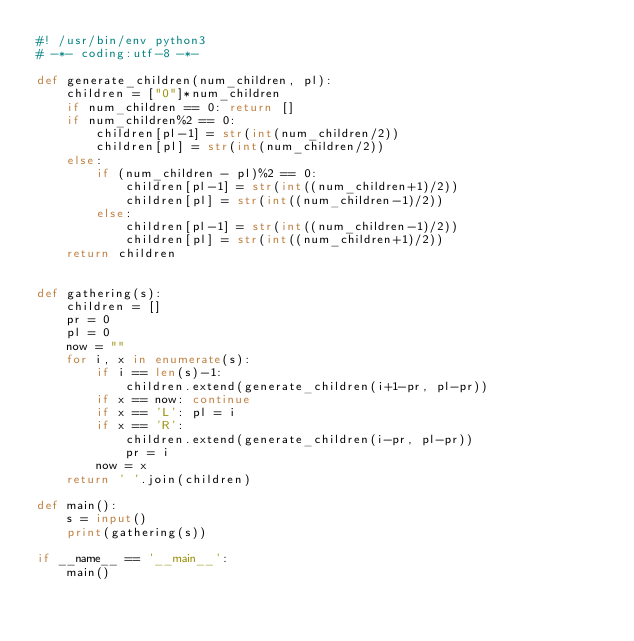Convert code to text. <code><loc_0><loc_0><loc_500><loc_500><_Python_>#! /usr/bin/env python3
# -*- coding:utf-8 -*-

def generate_children(num_children, pl):
    children = ["0"]*num_children
    if num_children == 0: return []
    if num_children%2 == 0:
        children[pl-1] = str(int(num_children/2))
        children[pl] = str(int(num_children/2))
    else:
        if (num_children - pl)%2 == 0:
            children[pl-1] = str(int((num_children+1)/2))
            children[pl] = str(int((num_children-1)/2))
        else:
            children[pl-1] = str(int((num_children-1)/2))
            children[pl] = str(int((num_children+1)/2))
    return children


def gathering(s):
    children = []
    pr = 0
    pl = 0
    now = ""
    for i, x in enumerate(s):
        if i == len(s)-1:
            children.extend(generate_children(i+1-pr, pl-pr))
        if x == now: continue
        if x == 'L': pl = i
        if x == 'R':
            children.extend(generate_children(i-pr, pl-pr))
            pr = i
        now = x
    return ' '.join(children)

def main():
    s = input()
    print(gathering(s))

if __name__ == '__main__':
    main()
</code> 